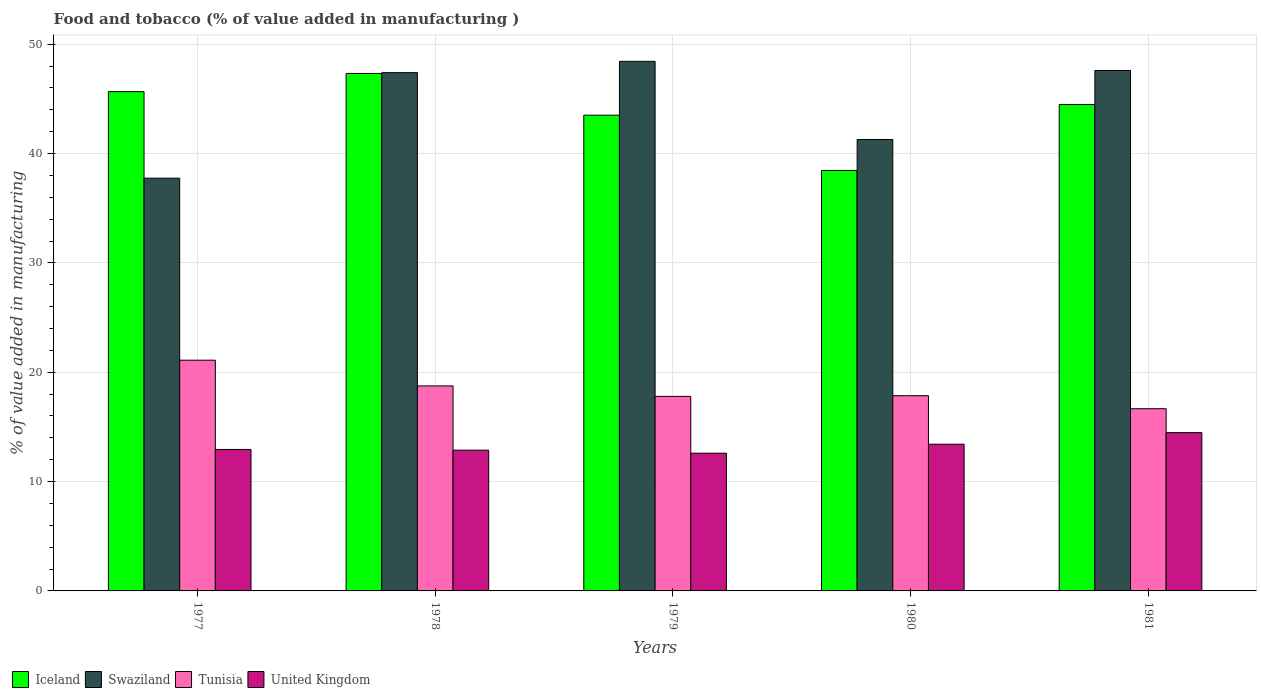How many bars are there on the 5th tick from the left?
Ensure brevity in your answer.  4. How many bars are there on the 4th tick from the right?
Your answer should be compact. 4. What is the label of the 2nd group of bars from the left?
Keep it short and to the point. 1978. In how many cases, is the number of bars for a given year not equal to the number of legend labels?
Your answer should be compact. 0. What is the value added in manufacturing food and tobacco in Iceland in 1977?
Make the answer very short. 45.66. Across all years, what is the maximum value added in manufacturing food and tobacco in United Kingdom?
Offer a very short reply. 14.48. Across all years, what is the minimum value added in manufacturing food and tobacco in Swaziland?
Make the answer very short. 37.75. In which year was the value added in manufacturing food and tobacco in Iceland maximum?
Provide a succinct answer. 1978. What is the total value added in manufacturing food and tobacco in Swaziland in the graph?
Give a very brief answer. 222.46. What is the difference between the value added in manufacturing food and tobacco in Iceland in 1978 and that in 1980?
Give a very brief answer. 8.87. What is the difference between the value added in manufacturing food and tobacco in United Kingdom in 1981 and the value added in manufacturing food and tobacco in Tunisia in 1977?
Offer a terse response. -6.62. What is the average value added in manufacturing food and tobacco in United Kingdom per year?
Provide a short and direct response. 13.26. In the year 1978, what is the difference between the value added in manufacturing food and tobacco in Swaziland and value added in manufacturing food and tobacco in United Kingdom?
Your answer should be very brief. 34.53. In how many years, is the value added in manufacturing food and tobacco in Swaziland greater than 36 %?
Keep it short and to the point. 5. What is the ratio of the value added in manufacturing food and tobacco in Swaziland in 1979 to that in 1980?
Your answer should be compact. 1.17. Is the value added in manufacturing food and tobacco in Tunisia in 1978 less than that in 1979?
Your answer should be compact. No. Is the difference between the value added in manufacturing food and tobacco in Swaziland in 1979 and 1981 greater than the difference between the value added in manufacturing food and tobacco in United Kingdom in 1979 and 1981?
Offer a very short reply. Yes. What is the difference between the highest and the second highest value added in manufacturing food and tobacco in United Kingdom?
Your answer should be compact. 1.06. What is the difference between the highest and the lowest value added in manufacturing food and tobacco in Tunisia?
Provide a succinct answer. 4.44. In how many years, is the value added in manufacturing food and tobacco in Swaziland greater than the average value added in manufacturing food and tobacco in Swaziland taken over all years?
Your answer should be very brief. 3. What does the 1st bar from the left in 1979 represents?
Offer a very short reply. Iceland. What does the 3rd bar from the right in 1979 represents?
Your answer should be compact. Swaziland. How many bars are there?
Your answer should be compact. 20. How many years are there in the graph?
Make the answer very short. 5. What is the difference between two consecutive major ticks on the Y-axis?
Provide a short and direct response. 10. Does the graph contain any zero values?
Your answer should be compact. No. How are the legend labels stacked?
Your answer should be compact. Horizontal. What is the title of the graph?
Your answer should be very brief. Food and tobacco (% of value added in manufacturing ). Does "Curacao" appear as one of the legend labels in the graph?
Your answer should be compact. No. What is the label or title of the X-axis?
Your answer should be very brief. Years. What is the label or title of the Y-axis?
Your answer should be compact. % of value added in manufacturing. What is the % of value added in manufacturing in Iceland in 1977?
Keep it short and to the point. 45.66. What is the % of value added in manufacturing of Swaziland in 1977?
Your response must be concise. 37.75. What is the % of value added in manufacturing in Tunisia in 1977?
Give a very brief answer. 21.1. What is the % of value added in manufacturing in United Kingdom in 1977?
Your answer should be very brief. 12.94. What is the % of value added in manufacturing in Iceland in 1978?
Offer a very short reply. 47.33. What is the % of value added in manufacturing in Swaziland in 1978?
Your response must be concise. 47.4. What is the % of value added in manufacturing of Tunisia in 1978?
Provide a short and direct response. 18.75. What is the % of value added in manufacturing in United Kingdom in 1978?
Keep it short and to the point. 12.87. What is the % of value added in manufacturing of Iceland in 1979?
Your response must be concise. 43.51. What is the % of value added in manufacturing in Swaziland in 1979?
Your response must be concise. 48.43. What is the % of value added in manufacturing of Tunisia in 1979?
Provide a succinct answer. 17.79. What is the % of value added in manufacturing of United Kingdom in 1979?
Your answer should be compact. 12.6. What is the % of value added in manufacturing of Iceland in 1980?
Make the answer very short. 38.45. What is the % of value added in manufacturing in Swaziland in 1980?
Your response must be concise. 41.28. What is the % of value added in manufacturing in Tunisia in 1980?
Keep it short and to the point. 17.85. What is the % of value added in manufacturing of United Kingdom in 1980?
Your answer should be compact. 13.42. What is the % of value added in manufacturing of Iceland in 1981?
Offer a terse response. 44.48. What is the % of value added in manufacturing in Swaziland in 1981?
Your answer should be very brief. 47.6. What is the % of value added in manufacturing in Tunisia in 1981?
Offer a terse response. 16.66. What is the % of value added in manufacturing in United Kingdom in 1981?
Offer a terse response. 14.48. Across all years, what is the maximum % of value added in manufacturing of Iceland?
Give a very brief answer. 47.33. Across all years, what is the maximum % of value added in manufacturing of Swaziland?
Give a very brief answer. 48.43. Across all years, what is the maximum % of value added in manufacturing of Tunisia?
Your response must be concise. 21.1. Across all years, what is the maximum % of value added in manufacturing of United Kingdom?
Your answer should be compact. 14.48. Across all years, what is the minimum % of value added in manufacturing in Iceland?
Ensure brevity in your answer.  38.45. Across all years, what is the minimum % of value added in manufacturing of Swaziland?
Make the answer very short. 37.75. Across all years, what is the minimum % of value added in manufacturing in Tunisia?
Your answer should be very brief. 16.66. Across all years, what is the minimum % of value added in manufacturing of United Kingdom?
Give a very brief answer. 12.6. What is the total % of value added in manufacturing in Iceland in the graph?
Offer a very short reply. 219.43. What is the total % of value added in manufacturing in Swaziland in the graph?
Provide a succinct answer. 222.46. What is the total % of value added in manufacturing of Tunisia in the graph?
Give a very brief answer. 92.16. What is the total % of value added in manufacturing in United Kingdom in the graph?
Provide a succinct answer. 66.3. What is the difference between the % of value added in manufacturing in Iceland in 1977 and that in 1978?
Your response must be concise. -1.66. What is the difference between the % of value added in manufacturing in Swaziland in 1977 and that in 1978?
Offer a very short reply. -9.65. What is the difference between the % of value added in manufacturing of Tunisia in 1977 and that in 1978?
Offer a very short reply. 2.35. What is the difference between the % of value added in manufacturing of United Kingdom in 1977 and that in 1978?
Make the answer very short. 0.06. What is the difference between the % of value added in manufacturing in Iceland in 1977 and that in 1979?
Provide a short and direct response. 2.16. What is the difference between the % of value added in manufacturing of Swaziland in 1977 and that in 1979?
Offer a terse response. -10.68. What is the difference between the % of value added in manufacturing in Tunisia in 1977 and that in 1979?
Provide a short and direct response. 3.31. What is the difference between the % of value added in manufacturing of United Kingdom in 1977 and that in 1979?
Provide a succinct answer. 0.34. What is the difference between the % of value added in manufacturing of Iceland in 1977 and that in 1980?
Your answer should be compact. 7.21. What is the difference between the % of value added in manufacturing in Swaziland in 1977 and that in 1980?
Keep it short and to the point. -3.54. What is the difference between the % of value added in manufacturing of Tunisia in 1977 and that in 1980?
Provide a short and direct response. 3.25. What is the difference between the % of value added in manufacturing in United Kingdom in 1977 and that in 1980?
Make the answer very short. -0.48. What is the difference between the % of value added in manufacturing of Iceland in 1977 and that in 1981?
Provide a succinct answer. 1.18. What is the difference between the % of value added in manufacturing of Swaziland in 1977 and that in 1981?
Your answer should be very brief. -9.85. What is the difference between the % of value added in manufacturing of Tunisia in 1977 and that in 1981?
Keep it short and to the point. 4.44. What is the difference between the % of value added in manufacturing of United Kingdom in 1977 and that in 1981?
Provide a short and direct response. -1.54. What is the difference between the % of value added in manufacturing in Iceland in 1978 and that in 1979?
Keep it short and to the point. 3.82. What is the difference between the % of value added in manufacturing of Swaziland in 1978 and that in 1979?
Ensure brevity in your answer.  -1.03. What is the difference between the % of value added in manufacturing of Tunisia in 1978 and that in 1979?
Provide a short and direct response. 0.96. What is the difference between the % of value added in manufacturing of United Kingdom in 1978 and that in 1979?
Make the answer very short. 0.28. What is the difference between the % of value added in manufacturing of Iceland in 1978 and that in 1980?
Your answer should be very brief. 8.87. What is the difference between the % of value added in manufacturing in Swaziland in 1978 and that in 1980?
Offer a terse response. 6.11. What is the difference between the % of value added in manufacturing in Tunisia in 1978 and that in 1980?
Give a very brief answer. 0.89. What is the difference between the % of value added in manufacturing in United Kingdom in 1978 and that in 1980?
Offer a terse response. -0.54. What is the difference between the % of value added in manufacturing in Iceland in 1978 and that in 1981?
Keep it short and to the point. 2.85. What is the difference between the % of value added in manufacturing in Swaziland in 1978 and that in 1981?
Give a very brief answer. -0.2. What is the difference between the % of value added in manufacturing in Tunisia in 1978 and that in 1981?
Your answer should be compact. 2.09. What is the difference between the % of value added in manufacturing of United Kingdom in 1978 and that in 1981?
Offer a very short reply. -1.6. What is the difference between the % of value added in manufacturing of Iceland in 1979 and that in 1980?
Make the answer very short. 5.05. What is the difference between the % of value added in manufacturing in Swaziland in 1979 and that in 1980?
Offer a very short reply. 7.15. What is the difference between the % of value added in manufacturing in Tunisia in 1979 and that in 1980?
Give a very brief answer. -0.06. What is the difference between the % of value added in manufacturing in United Kingdom in 1979 and that in 1980?
Give a very brief answer. -0.82. What is the difference between the % of value added in manufacturing of Iceland in 1979 and that in 1981?
Your answer should be compact. -0.97. What is the difference between the % of value added in manufacturing of Swaziland in 1979 and that in 1981?
Your response must be concise. 0.84. What is the difference between the % of value added in manufacturing in Tunisia in 1979 and that in 1981?
Your answer should be very brief. 1.13. What is the difference between the % of value added in manufacturing of United Kingdom in 1979 and that in 1981?
Offer a very short reply. -1.88. What is the difference between the % of value added in manufacturing in Iceland in 1980 and that in 1981?
Give a very brief answer. -6.03. What is the difference between the % of value added in manufacturing in Swaziland in 1980 and that in 1981?
Ensure brevity in your answer.  -6.31. What is the difference between the % of value added in manufacturing in Tunisia in 1980 and that in 1981?
Provide a short and direct response. 1.19. What is the difference between the % of value added in manufacturing in United Kingdom in 1980 and that in 1981?
Offer a terse response. -1.06. What is the difference between the % of value added in manufacturing in Iceland in 1977 and the % of value added in manufacturing in Swaziland in 1978?
Your answer should be very brief. -1.73. What is the difference between the % of value added in manufacturing of Iceland in 1977 and the % of value added in manufacturing of Tunisia in 1978?
Provide a short and direct response. 26.91. What is the difference between the % of value added in manufacturing of Iceland in 1977 and the % of value added in manufacturing of United Kingdom in 1978?
Your response must be concise. 32.79. What is the difference between the % of value added in manufacturing in Swaziland in 1977 and the % of value added in manufacturing in Tunisia in 1978?
Give a very brief answer. 19. What is the difference between the % of value added in manufacturing of Swaziland in 1977 and the % of value added in manufacturing of United Kingdom in 1978?
Provide a succinct answer. 24.87. What is the difference between the % of value added in manufacturing in Tunisia in 1977 and the % of value added in manufacturing in United Kingdom in 1978?
Make the answer very short. 8.23. What is the difference between the % of value added in manufacturing of Iceland in 1977 and the % of value added in manufacturing of Swaziland in 1979?
Make the answer very short. -2.77. What is the difference between the % of value added in manufacturing in Iceland in 1977 and the % of value added in manufacturing in Tunisia in 1979?
Provide a short and direct response. 27.87. What is the difference between the % of value added in manufacturing of Iceland in 1977 and the % of value added in manufacturing of United Kingdom in 1979?
Your answer should be compact. 33.07. What is the difference between the % of value added in manufacturing in Swaziland in 1977 and the % of value added in manufacturing in Tunisia in 1979?
Provide a short and direct response. 19.96. What is the difference between the % of value added in manufacturing in Swaziland in 1977 and the % of value added in manufacturing in United Kingdom in 1979?
Make the answer very short. 25.15. What is the difference between the % of value added in manufacturing of Tunisia in 1977 and the % of value added in manufacturing of United Kingdom in 1979?
Provide a succinct answer. 8.51. What is the difference between the % of value added in manufacturing of Iceland in 1977 and the % of value added in manufacturing of Swaziland in 1980?
Your response must be concise. 4.38. What is the difference between the % of value added in manufacturing in Iceland in 1977 and the % of value added in manufacturing in Tunisia in 1980?
Offer a very short reply. 27.81. What is the difference between the % of value added in manufacturing of Iceland in 1977 and the % of value added in manufacturing of United Kingdom in 1980?
Keep it short and to the point. 32.25. What is the difference between the % of value added in manufacturing of Swaziland in 1977 and the % of value added in manufacturing of Tunisia in 1980?
Provide a short and direct response. 19.89. What is the difference between the % of value added in manufacturing in Swaziland in 1977 and the % of value added in manufacturing in United Kingdom in 1980?
Offer a very short reply. 24.33. What is the difference between the % of value added in manufacturing in Tunisia in 1977 and the % of value added in manufacturing in United Kingdom in 1980?
Make the answer very short. 7.68. What is the difference between the % of value added in manufacturing in Iceland in 1977 and the % of value added in manufacturing in Swaziland in 1981?
Make the answer very short. -1.93. What is the difference between the % of value added in manufacturing in Iceland in 1977 and the % of value added in manufacturing in Tunisia in 1981?
Your response must be concise. 29. What is the difference between the % of value added in manufacturing of Iceland in 1977 and the % of value added in manufacturing of United Kingdom in 1981?
Ensure brevity in your answer.  31.19. What is the difference between the % of value added in manufacturing of Swaziland in 1977 and the % of value added in manufacturing of Tunisia in 1981?
Offer a terse response. 21.09. What is the difference between the % of value added in manufacturing in Swaziland in 1977 and the % of value added in manufacturing in United Kingdom in 1981?
Give a very brief answer. 23.27. What is the difference between the % of value added in manufacturing of Tunisia in 1977 and the % of value added in manufacturing of United Kingdom in 1981?
Your answer should be very brief. 6.62. What is the difference between the % of value added in manufacturing in Iceland in 1978 and the % of value added in manufacturing in Swaziland in 1979?
Keep it short and to the point. -1.11. What is the difference between the % of value added in manufacturing of Iceland in 1978 and the % of value added in manufacturing of Tunisia in 1979?
Offer a terse response. 29.54. What is the difference between the % of value added in manufacturing of Iceland in 1978 and the % of value added in manufacturing of United Kingdom in 1979?
Provide a short and direct response. 34.73. What is the difference between the % of value added in manufacturing of Swaziland in 1978 and the % of value added in manufacturing of Tunisia in 1979?
Offer a very short reply. 29.61. What is the difference between the % of value added in manufacturing of Swaziland in 1978 and the % of value added in manufacturing of United Kingdom in 1979?
Your answer should be compact. 34.8. What is the difference between the % of value added in manufacturing in Tunisia in 1978 and the % of value added in manufacturing in United Kingdom in 1979?
Offer a terse response. 6.15. What is the difference between the % of value added in manufacturing in Iceland in 1978 and the % of value added in manufacturing in Swaziland in 1980?
Provide a succinct answer. 6.04. What is the difference between the % of value added in manufacturing of Iceland in 1978 and the % of value added in manufacturing of Tunisia in 1980?
Offer a very short reply. 29.47. What is the difference between the % of value added in manufacturing in Iceland in 1978 and the % of value added in manufacturing in United Kingdom in 1980?
Keep it short and to the point. 33.91. What is the difference between the % of value added in manufacturing in Swaziland in 1978 and the % of value added in manufacturing in Tunisia in 1980?
Offer a terse response. 29.54. What is the difference between the % of value added in manufacturing in Swaziland in 1978 and the % of value added in manufacturing in United Kingdom in 1980?
Offer a very short reply. 33.98. What is the difference between the % of value added in manufacturing of Tunisia in 1978 and the % of value added in manufacturing of United Kingdom in 1980?
Make the answer very short. 5.33. What is the difference between the % of value added in manufacturing in Iceland in 1978 and the % of value added in manufacturing in Swaziland in 1981?
Your answer should be very brief. -0.27. What is the difference between the % of value added in manufacturing of Iceland in 1978 and the % of value added in manufacturing of Tunisia in 1981?
Keep it short and to the point. 30.66. What is the difference between the % of value added in manufacturing in Iceland in 1978 and the % of value added in manufacturing in United Kingdom in 1981?
Ensure brevity in your answer.  32.85. What is the difference between the % of value added in manufacturing in Swaziland in 1978 and the % of value added in manufacturing in Tunisia in 1981?
Provide a short and direct response. 30.74. What is the difference between the % of value added in manufacturing of Swaziland in 1978 and the % of value added in manufacturing of United Kingdom in 1981?
Your response must be concise. 32.92. What is the difference between the % of value added in manufacturing of Tunisia in 1978 and the % of value added in manufacturing of United Kingdom in 1981?
Make the answer very short. 4.27. What is the difference between the % of value added in manufacturing of Iceland in 1979 and the % of value added in manufacturing of Swaziland in 1980?
Give a very brief answer. 2.22. What is the difference between the % of value added in manufacturing in Iceland in 1979 and the % of value added in manufacturing in Tunisia in 1980?
Provide a short and direct response. 25.65. What is the difference between the % of value added in manufacturing of Iceland in 1979 and the % of value added in manufacturing of United Kingdom in 1980?
Offer a terse response. 30.09. What is the difference between the % of value added in manufacturing in Swaziland in 1979 and the % of value added in manufacturing in Tunisia in 1980?
Offer a very short reply. 30.58. What is the difference between the % of value added in manufacturing of Swaziland in 1979 and the % of value added in manufacturing of United Kingdom in 1980?
Offer a terse response. 35.01. What is the difference between the % of value added in manufacturing of Tunisia in 1979 and the % of value added in manufacturing of United Kingdom in 1980?
Your answer should be compact. 4.37. What is the difference between the % of value added in manufacturing in Iceland in 1979 and the % of value added in manufacturing in Swaziland in 1981?
Provide a short and direct response. -4.09. What is the difference between the % of value added in manufacturing in Iceland in 1979 and the % of value added in manufacturing in Tunisia in 1981?
Offer a terse response. 26.84. What is the difference between the % of value added in manufacturing in Iceland in 1979 and the % of value added in manufacturing in United Kingdom in 1981?
Give a very brief answer. 29.03. What is the difference between the % of value added in manufacturing of Swaziland in 1979 and the % of value added in manufacturing of Tunisia in 1981?
Give a very brief answer. 31.77. What is the difference between the % of value added in manufacturing in Swaziland in 1979 and the % of value added in manufacturing in United Kingdom in 1981?
Give a very brief answer. 33.95. What is the difference between the % of value added in manufacturing of Tunisia in 1979 and the % of value added in manufacturing of United Kingdom in 1981?
Your answer should be compact. 3.31. What is the difference between the % of value added in manufacturing in Iceland in 1980 and the % of value added in manufacturing in Swaziland in 1981?
Keep it short and to the point. -9.14. What is the difference between the % of value added in manufacturing of Iceland in 1980 and the % of value added in manufacturing of Tunisia in 1981?
Provide a short and direct response. 21.79. What is the difference between the % of value added in manufacturing in Iceland in 1980 and the % of value added in manufacturing in United Kingdom in 1981?
Provide a short and direct response. 23.98. What is the difference between the % of value added in manufacturing in Swaziland in 1980 and the % of value added in manufacturing in Tunisia in 1981?
Ensure brevity in your answer.  24.62. What is the difference between the % of value added in manufacturing of Swaziland in 1980 and the % of value added in manufacturing of United Kingdom in 1981?
Your response must be concise. 26.81. What is the difference between the % of value added in manufacturing in Tunisia in 1980 and the % of value added in manufacturing in United Kingdom in 1981?
Make the answer very short. 3.38. What is the average % of value added in manufacturing in Iceland per year?
Ensure brevity in your answer.  43.89. What is the average % of value added in manufacturing in Swaziland per year?
Your answer should be very brief. 44.49. What is the average % of value added in manufacturing in Tunisia per year?
Your answer should be compact. 18.43. What is the average % of value added in manufacturing of United Kingdom per year?
Your response must be concise. 13.26. In the year 1977, what is the difference between the % of value added in manufacturing of Iceland and % of value added in manufacturing of Swaziland?
Keep it short and to the point. 7.92. In the year 1977, what is the difference between the % of value added in manufacturing in Iceland and % of value added in manufacturing in Tunisia?
Your answer should be compact. 24.56. In the year 1977, what is the difference between the % of value added in manufacturing in Iceland and % of value added in manufacturing in United Kingdom?
Provide a succinct answer. 32.73. In the year 1977, what is the difference between the % of value added in manufacturing of Swaziland and % of value added in manufacturing of Tunisia?
Give a very brief answer. 16.65. In the year 1977, what is the difference between the % of value added in manufacturing in Swaziland and % of value added in manufacturing in United Kingdom?
Give a very brief answer. 24.81. In the year 1977, what is the difference between the % of value added in manufacturing of Tunisia and % of value added in manufacturing of United Kingdom?
Keep it short and to the point. 8.16. In the year 1978, what is the difference between the % of value added in manufacturing in Iceland and % of value added in manufacturing in Swaziland?
Keep it short and to the point. -0.07. In the year 1978, what is the difference between the % of value added in manufacturing in Iceland and % of value added in manufacturing in Tunisia?
Ensure brevity in your answer.  28.58. In the year 1978, what is the difference between the % of value added in manufacturing of Iceland and % of value added in manufacturing of United Kingdom?
Provide a short and direct response. 34.45. In the year 1978, what is the difference between the % of value added in manufacturing of Swaziland and % of value added in manufacturing of Tunisia?
Provide a short and direct response. 28.65. In the year 1978, what is the difference between the % of value added in manufacturing in Swaziland and % of value added in manufacturing in United Kingdom?
Provide a short and direct response. 34.53. In the year 1978, what is the difference between the % of value added in manufacturing in Tunisia and % of value added in manufacturing in United Kingdom?
Provide a short and direct response. 5.88. In the year 1979, what is the difference between the % of value added in manufacturing of Iceland and % of value added in manufacturing of Swaziland?
Keep it short and to the point. -4.92. In the year 1979, what is the difference between the % of value added in manufacturing in Iceland and % of value added in manufacturing in Tunisia?
Provide a short and direct response. 25.72. In the year 1979, what is the difference between the % of value added in manufacturing of Iceland and % of value added in manufacturing of United Kingdom?
Give a very brief answer. 30.91. In the year 1979, what is the difference between the % of value added in manufacturing in Swaziland and % of value added in manufacturing in Tunisia?
Your answer should be very brief. 30.64. In the year 1979, what is the difference between the % of value added in manufacturing of Swaziland and % of value added in manufacturing of United Kingdom?
Make the answer very short. 35.84. In the year 1979, what is the difference between the % of value added in manufacturing in Tunisia and % of value added in manufacturing in United Kingdom?
Your response must be concise. 5.2. In the year 1980, what is the difference between the % of value added in manufacturing of Iceland and % of value added in manufacturing of Swaziland?
Your answer should be very brief. -2.83. In the year 1980, what is the difference between the % of value added in manufacturing of Iceland and % of value added in manufacturing of Tunisia?
Provide a short and direct response. 20.6. In the year 1980, what is the difference between the % of value added in manufacturing in Iceland and % of value added in manufacturing in United Kingdom?
Your response must be concise. 25.04. In the year 1980, what is the difference between the % of value added in manufacturing in Swaziland and % of value added in manufacturing in Tunisia?
Provide a succinct answer. 23.43. In the year 1980, what is the difference between the % of value added in manufacturing in Swaziland and % of value added in manufacturing in United Kingdom?
Your answer should be compact. 27.87. In the year 1980, what is the difference between the % of value added in manufacturing in Tunisia and % of value added in manufacturing in United Kingdom?
Provide a succinct answer. 4.44. In the year 1981, what is the difference between the % of value added in manufacturing in Iceland and % of value added in manufacturing in Swaziland?
Provide a succinct answer. -3.11. In the year 1981, what is the difference between the % of value added in manufacturing in Iceland and % of value added in manufacturing in Tunisia?
Offer a very short reply. 27.82. In the year 1981, what is the difference between the % of value added in manufacturing in Iceland and % of value added in manufacturing in United Kingdom?
Keep it short and to the point. 30. In the year 1981, what is the difference between the % of value added in manufacturing of Swaziland and % of value added in manufacturing of Tunisia?
Your response must be concise. 30.93. In the year 1981, what is the difference between the % of value added in manufacturing of Swaziland and % of value added in manufacturing of United Kingdom?
Make the answer very short. 33.12. In the year 1981, what is the difference between the % of value added in manufacturing in Tunisia and % of value added in manufacturing in United Kingdom?
Provide a succinct answer. 2.19. What is the ratio of the % of value added in manufacturing of Iceland in 1977 to that in 1978?
Give a very brief answer. 0.96. What is the ratio of the % of value added in manufacturing of Swaziland in 1977 to that in 1978?
Give a very brief answer. 0.8. What is the ratio of the % of value added in manufacturing in Tunisia in 1977 to that in 1978?
Keep it short and to the point. 1.13. What is the ratio of the % of value added in manufacturing of Iceland in 1977 to that in 1979?
Make the answer very short. 1.05. What is the ratio of the % of value added in manufacturing in Swaziland in 1977 to that in 1979?
Your response must be concise. 0.78. What is the ratio of the % of value added in manufacturing of Tunisia in 1977 to that in 1979?
Provide a succinct answer. 1.19. What is the ratio of the % of value added in manufacturing in United Kingdom in 1977 to that in 1979?
Give a very brief answer. 1.03. What is the ratio of the % of value added in manufacturing in Iceland in 1977 to that in 1980?
Your answer should be very brief. 1.19. What is the ratio of the % of value added in manufacturing in Swaziland in 1977 to that in 1980?
Offer a very short reply. 0.91. What is the ratio of the % of value added in manufacturing of Tunisia in 1977 to that in 1980?
Offer a terse response. 1.18. What is the ratio of the % of value added in manufacturing in United Kingdom in 1977 to that in 1980?
Your answer should be very brief. 0.96. What is the ratio of the % of value added in manufacturing in Iceland in 1977 to that in 1981?
Offer a very short reply. 1.03. What is the ratio of the % of value added in manufacturing in Swaziland in 1977 to that in 1981?
Provide a succinct answer. 0.79. What is the ratio of the % of value added in manufacturing in Tunisia in 1977 to that in 1981?
Offer a terse response. 1.27. What is the ratio of the % of value added in manufacturing of United Kingdom in 1977 to that in 1981?
Give a very brief answer. 0.89. What is the ratio of the % of value added in manufacturing of Iceland in 1978 to that in 1979?
Provide a succinct answer. 1.09. What is the ratio of the % of value added in manufacturing in Swaziland in 1978 to that in 1979?
Offer a very short reply. 0.98. What is the ratio of the % of value added in manufacturing of Tunisia in 1978 to that in 1979?
Ensure brevity in your answer.  1.05. What is the ratio of the % of value added in manufacturing in Iceland in 1978 to that in 1980?
Provide a short and direct response. 1.23. What is the ratio of the % of value added in manufacturing of Swaziland in 1978 to that in 1980?
Your answer should be compact. 1.15. What is the ratio of the % of value added in manufacturing in Tunisia in 1978 to that in 1980?
Offer a very short reply. 1.05. What is the ratio of the % of value added in manufacturing in United Kingdom in 1978 to that in 1980?
Your answer should be compact. 0.96. What is the ratio of the % of value added in manufacturing of Iceland in 1978 to that in 1981?
Your answer should be very brief. 1.06. What is the ratio of the % of value added in manufacturing of Swaziland in 1978 to that in 1981?
Provide a succinct answer. 1. What is the ratio of the % of value added in manufacturing of Tunisia in 1978 to that in 1981?
Make the answer very short. 1.13. What is the ratio of the % of value added in manufacturing of United Kingdom in 1978 to that in 1981?
Your answer should be compact. 0.89. What is the ratio of the % of value added in manufacturing of Iceland in 1979 to that in 1980?
Ensure brevity in your answer.  1.13. What is the ratio of the % of value added in manufacturing in Swaziland in 1979 to that in 1980?
Your response must be concise. 1.17. What is the ratio of the % of value added in manufacturing in United Kingdom in 1979 to that in 1980?
Offer a terse response. 0.94. What is the ratio of the % of value added in manufacturing in Iceland in 1979 to that in 1981?
Your answer should be very brief. 0.98. What is the ratio of the % of value added in manufacturing in Swaziland in 1979 to that in 1981?
Ensure brevity in your answer.  1.02. What is the ratio of the % of value added in manufacturing of Tunisia in 1979 to that in 1981?
Give a very brief answer. 1.07. What is the ratio of the % of value added in manufacturing of United Kingdom in 1979 to that in 1981?
Offer a very short reply. 0.87. What is the ratio of the % of value added in manufacturing in Iceland in 1980 to that in 1981?
Give a very brief answer. 0.86. What is the ratio of the % of value added in manufacturing in Swaziland in 1980 to that in 1981?
Give a very brief answer. 0.87. What is the ratio of the % of value added in manufacturing of Tunisia in 1980 to that in 1981?
Make the answer very short. 1.07. What is the ratio of the % of value added in manufacturing of United Kingdom in 1980 to that in 1981?
Provide a short and direct response. 0.93. What is the difference between the highest and the second highest % of value added in manufacturing in Iceland?
Your answer should be very brief. 1.66. What is the difference between the highest and the second highest % of value added in manufacturing in Swaziland?
Your answer should be compact. 0.84. What is the difference between the highest and the second highest % of value added in manufacturing in Tunisia?
Make the answer very short. 2.35. What is the difference between the highest and the second highest % of value added in manufacturing of United Kingdom?
Your response must be concise. 1.06. What is the difference between the highest and the lowest % of value added in manufacturing of Iceland?
Offer a very short reply. 8.87. What is the difference between the highest and the lowest % of value added in manufacturing in Swaziland?
Ensure brevity in your answer.  10.68. What is the difference between the highest and the lowest % of value added in manufacturing in Tunisia?
Make the answer very short. 4.44. What is the difference between the highest and the lowest % of value added in manufacturing in United Kingdom?
Your answer should be very brief. 1.88. 